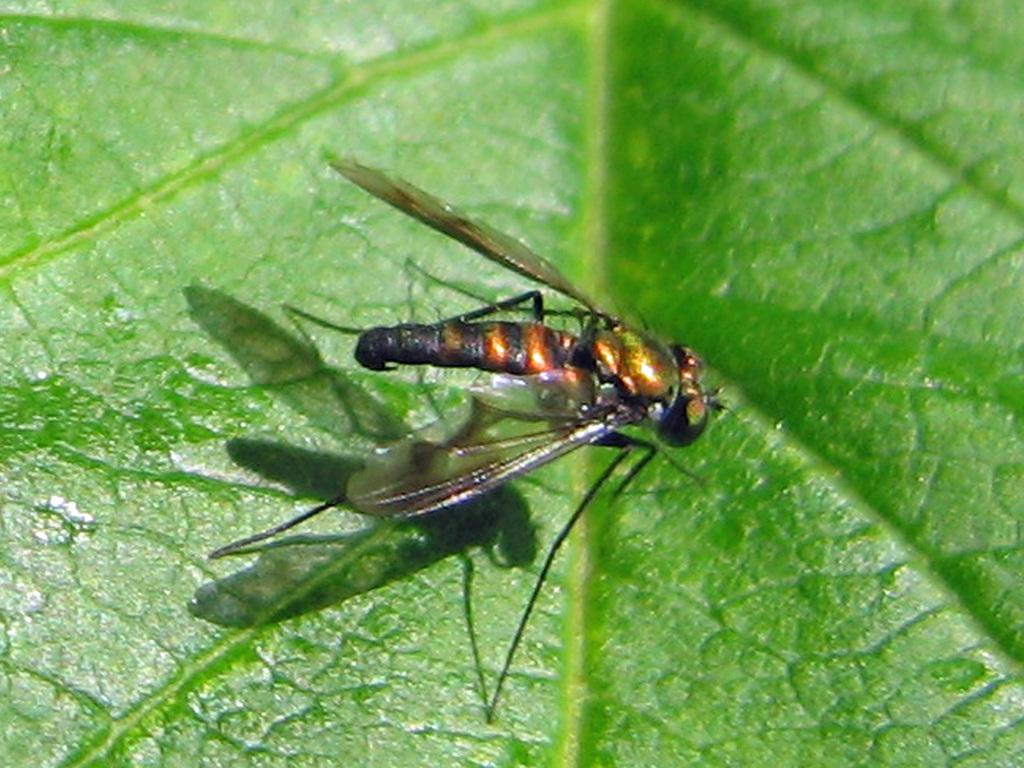What is present on the leaf in the image? There is an insect on the leaf in the image. What feature of the insect can be observed in the image? The insect has wings. What type of trouble is the insect causing on the table in the image? There is no table present in the image, and the insect is on a leaf, not causing any trouble. 